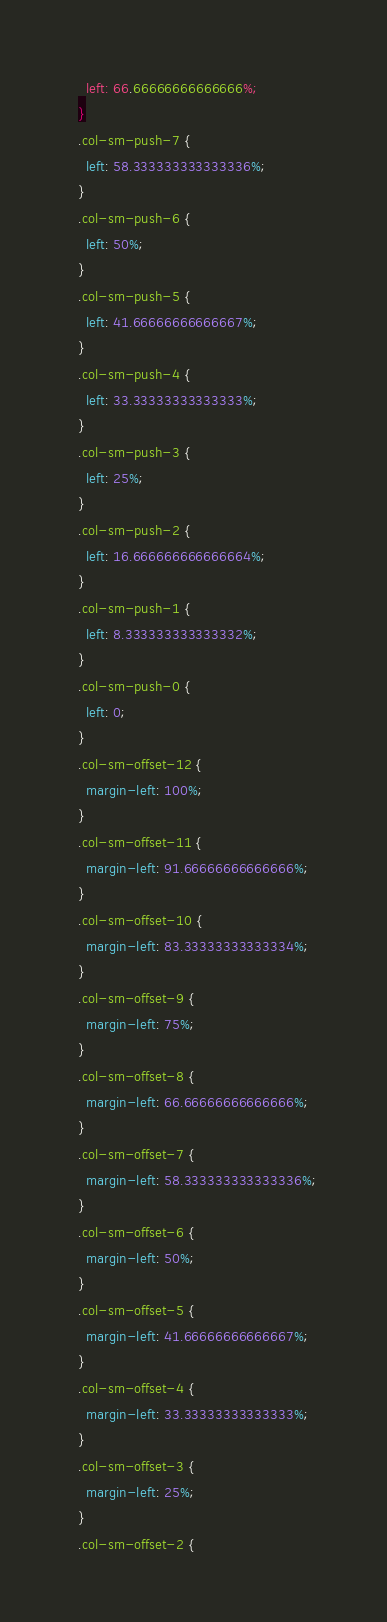Convert code to text. <code><loc_0><loc_0><loc_500><loc_500><_CSS_>    left: 66.66666666666666%;
  }
  .col-sm-push-7 {
    left: 58.333333333333336%;
  }
  .col-sm-push-6 {
    left: 50%;
  }
  .col-sm-push-5 {
    left: 41.66666666666667%;
  }
  .col-sm-push-4 {
    left: 33.33333333333333%;
  }
  .col-sm-push-3 {
    left: 25%;
  }
  .col-sm-push-2 {
    left: 16.666666666666664%;
  }
  .col-sm-push-1 {
    left: 8.333333333333332%;
  }
  .col-sm-push-0 {
    left: 0;
  }
  .col-sm-offset-12 {
    margin-left: 100%;
  }
  .col-sm-offset-11 {
    margin-left: 91.66666666666666%;
  }
  .col-sm-offset-10 {
    margin-left: 83.33333333333334%;
  }
  .col-sm-offset-9 {
    margin-left: 75%;
  }
  .col-sm-offset-8 {
    margin-left: 66.66666666666666%;
  }
  .col-sm-offset-7 {
    margin-left: 58.333333333333336%;
  }
  .col-sm-offset-6 {
    margin-left: 50%;
  }
  .col-sm-offset-5 {
    margin-left: 41.66666666666667%;
  }
  .col-sm-offset-4 {
    margin-left: 33.33333333333333%;
  }
  .col-sm-offset-3 {
    margin-left: 25%;
  }
  .col-sm-offset-2 {</code> 